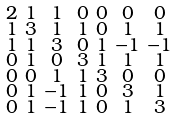Convert formula to latex. <formula><loc_0><loc_0><loc_500><loc_500>\begin{smallmatrix} 2 & 1 & 1 & 0 & 0 & 0 & 0 \\ 1 & 3 & 1 & 1 & 0 & 1 & 1 \\ 1 & 1 & 3 & 0 & 1 & - 1 & - 1 \\ 0 & 1 & 0 & 3 & 1 & 1 & 1 \\ 0 & 0 & 1 & 1 & 3 & 0 & 0 \\ 0 & 1 & - 1 & 1 & 0 & 3 & 1 \\ 0 & 1 & - 1 & 1 & 0 & 1 & 3 \end{smallmatrix}</formula> 